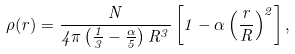<formula> <loc_0><loc_0><loc_500><loc_500>\rho ( r ) = \frac { N } { 4 \pi \left ( \frac { 1 } { 3 } - \frac { \alpha } { 5 } \right ) R ^ { 3 } } \left [ 1 - \alpha \left ( \frac { r } { R } \right ) ^ { 2 } \right ] ,</formula> 